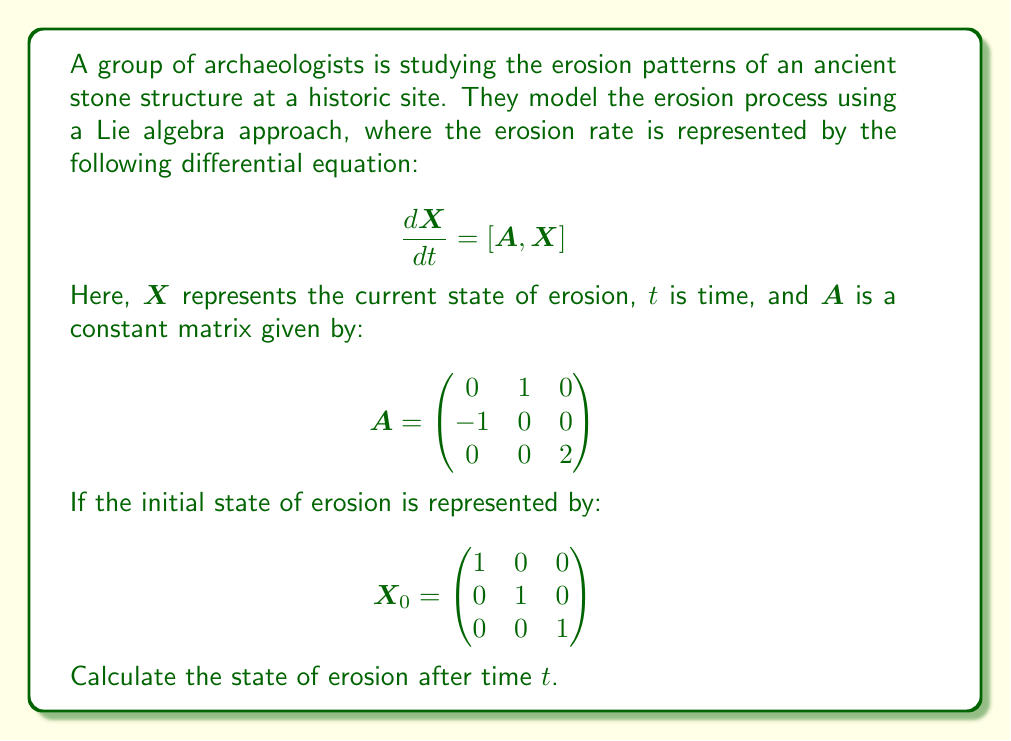Give your solution to this math problem. To solve this problem, we need to use the theory of Lie algebras and matrix exponentials. The solution to the differential equation $\frac{dX}{dt} = [A, X]$ with initial condition $X(0) = X_0$ is given by:

$$X(t) = e^{tA} X_0 e^{-tA}$$

Where $e^{tA}$ is the matrix exponential of $tA$. To calculate this, we need to diagonalize the matrix $A$.

1) First, let's find the eigenvalues of $A$:
   $det(A - \lambda I) = (\lambda^2 + 1)(2 - \lambda) = 0$
   So, the eigenvalues are $\lambda_1 = i$, $\lambda_2 = -i$, and $\lambda_3 = 2$

2) Now, we can write $A$ in its Jordan canonical form:
   $$A = PJP^{-1}$$
   Where $J = \begin{pmatrix}
   i & 0 & 0 \\
   0 & -i & 0 \\
   0 & 0 & 2
   \end{pmatrix}$

3) The matrix exponential of $tA$ can now be calculated as:
   $$e^{tA} = Pe^{tJ}P^{-1}$$

4) $e^{tJ}$ is easy to calculate:
   $$e^{tJ} = \begin{pmatrix}
   e^{it} & 0 & 0 \\
   0 & e^{-it} & 0 \\
   0 & 0 & e^{2t}
   \end{pmatrix}$$

5) After some calculations, we get:
   $$e^{tA} = \begin{pmatrix}
   \cos t & \sin t & 0 \\
   -\sin t & \cos t & 0 \\
   0 & 0 & e^{2t}
   \end{pmatrix}$$

6) Now we can calculate $X(t)$:
   $$X(t) = e^{tA} X_0 e^{-tA} = \begin{pmatrix}
   \cos^2 t + \sin^2 t & 0 & 0 \\
   0 & \cos^2 t + \sin^2 t & 0 \\
   0 & 0 & e^{2t}
   \end{pmatrix}$$
Answer: $$X(t) = \begin{pmatrix}
1 & 0 & 0 \\
0 & 1 & 0 \\
0 & 0 & e^{2t}
\end{pmatrix}$$ 